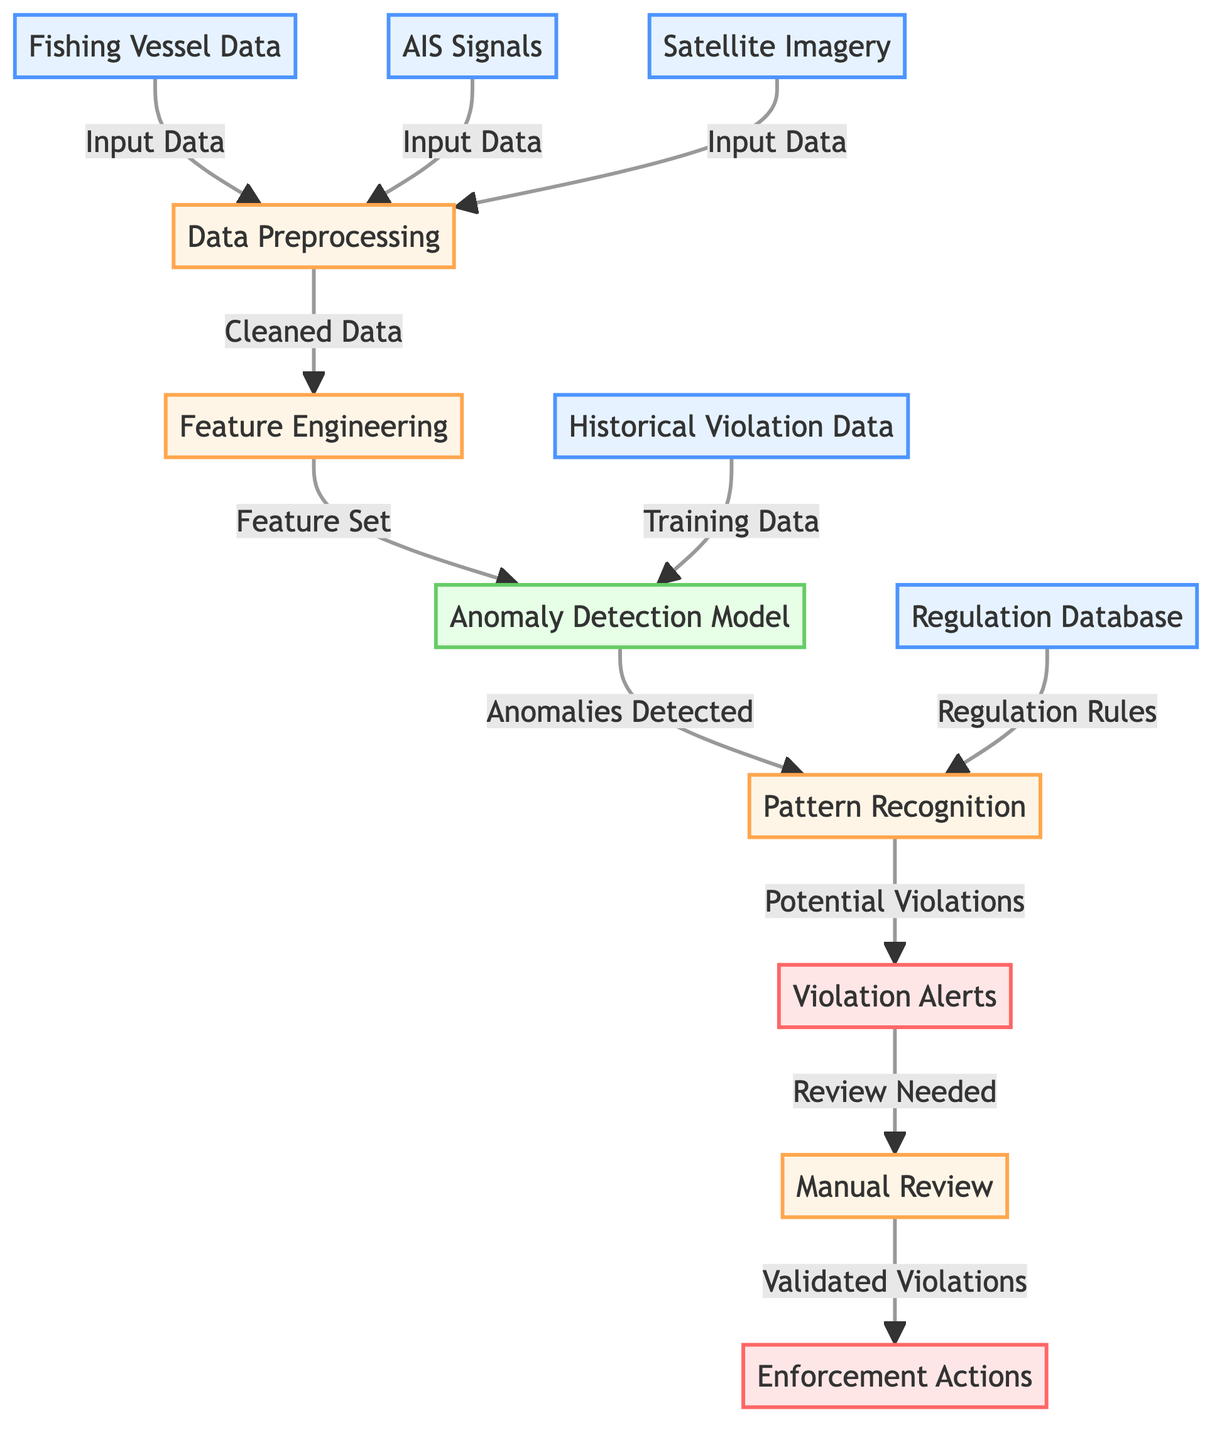What types of input data are used in this diagram? The diagram lists three types of input data: Fishing Vessel Data, AIS Signals, and Satellite Imagery at the top of the flowchart.
Answer: Fishing Vessel Data, AIS Signals, Satellite Imagery How many processes are involved in the anomaly detection flow? Upon examining the diagram, the processes are Data Preprocessing, Feature Engineering, Pattern Recognition, and Manual Review, totaling four processes.
Answer: 4 What is the output of the anomaly detection model? The output from the Anomaly Detection Model node is noted as "Anomalies Detected," which directly leads to the Pattern Recognition phase.
Answer: Anomalies Detected What is needed before enforcement actions can be taken? Referring to the diagram, after the Manual Review stage, validated violations are necessary before enforcement actions occur.
Answer: Validated Violations How does the Pattern Recognition process use input from both the anomaly detection model and the regulation database? The Pattern Recognition process combines outputs from the Anomaly Detection Model, which identifies potential violations, and the Regulation Database that contains regulations to assess those violations in conjunction.
Answer: Combines Outputs What is the relationship between the input data and the Data Preprocessing step? In the diagram, the input data (Fishing Vessel Data, AIS Signals, Satellite Imagery) flows into the Data Preprocessing step, indicating that all input data are processed to clean it for further analysis.
Answer: Input Data flows into Data Preprocessing What type of data is used to train the anomaly detection model? The diagram specifies that Historical Violation Data is used as the training data for the Anomaly Detection Model.
Answer: Historical Violation Data Which node indicates that violation alerts require review? The Violation Alerts node is directly linked to the Manual Review node, indicating that alerts necessitate further review.
Answer: Manual Review What indicates the flow of data from feature engineering to the anomaly detection model? The directed connection from the Feature Set output of the Feature Engineering process indicates the flow of the processed data into the Anomaly Detection Model.
Answer: Feature Set 